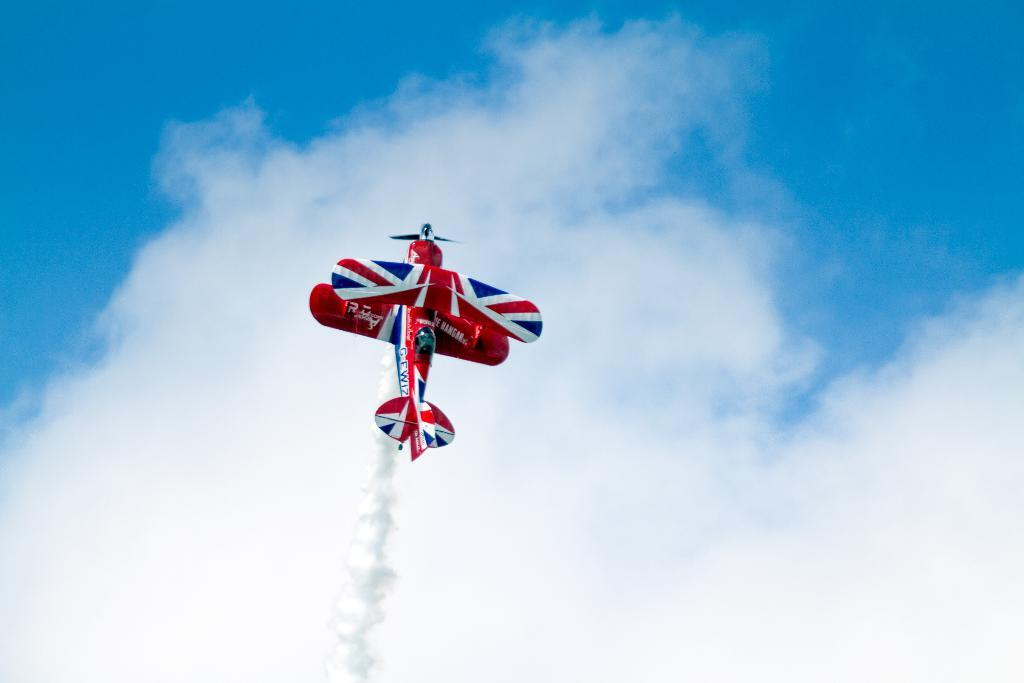What is the main subject of the image? The main subject of the image is an airplane. What is the airplane doing in the image? The airplane is flying in the air. What can be seen coming out of the airplane in the image? There is fume visible in the image. What is visible in the background of the image? The sky and clouds are visible in the background of the image. What type of paper can be seen being used for a basketball game in the image? There is no paper or basketball game present in the image; it features an airplane flying in the air. What kind of toys are visible in the image? There are no toys visible in the image; it only shows an airplane flying in the air. 